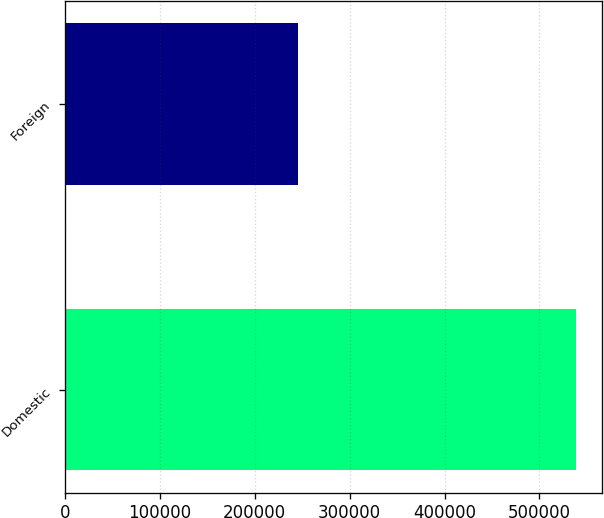Convert chart. <chart><loc_0><loc_0><loc_500><loc_500><bar_chart><fcel>Domestic<fcel>Foreign<nl><fcel>539031<fcel>245583<nl></chart> 